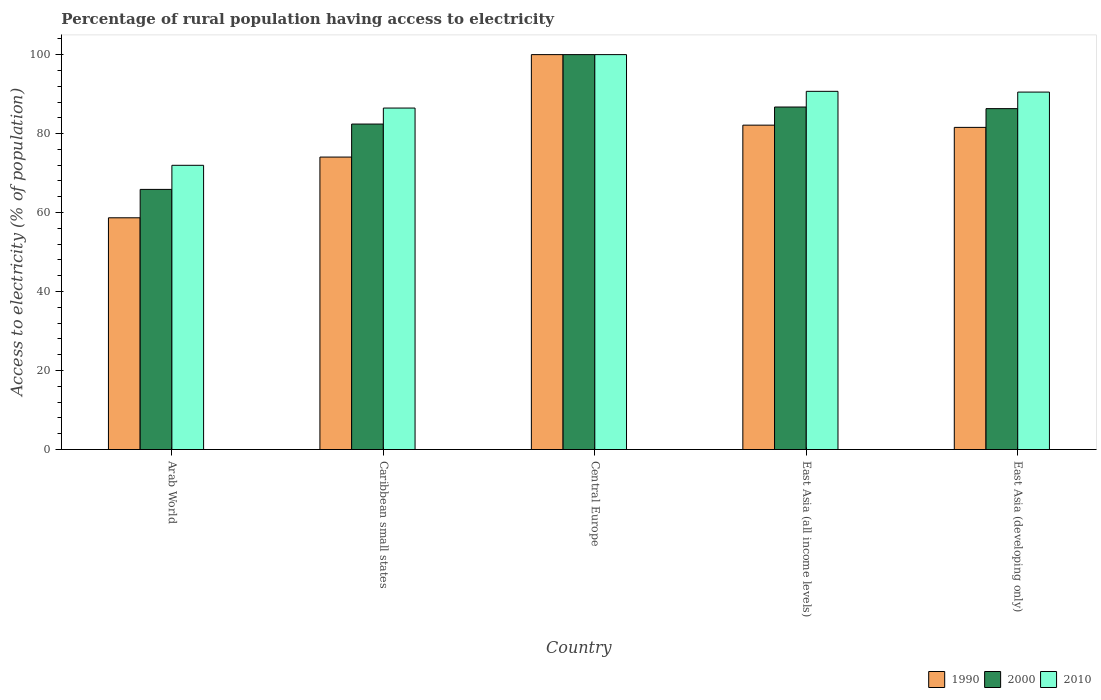How many groups of bars are there?
Keep it short and to the point. 5. What is the label of the 1st group of bars from the left?
Provide a short and direct response. Arab World. Across all countries, what is the maximum percentage of rural population having access to electricity in 1990?
Ensure brevity in your answer.  100. Across all countries, what is the minimum percentage of rural population having access to electricity in 2010?
Keep it short and to the point. 71.97. In which country was the percentage of rural population having access to electricity in 2000 maximum?
Ensure brevity in your answer.  Central Europe. In which country was the percentage of rural population having access to electricity in 2010 minimum?
Ensure brevity in your answer.  Arab World. What is the total percentage of rural population having access to electricity in 2010 in the graph?
Provide a succinct answer. 439.66. What is the difference between the percentage of rural population having access to electricity in 2010 in Caribbean small states and that in East Asia (developing only)?
Keep it short and to the point. -4.04. What is the difference between the percentage of rural population having access to electricity in 2010 in East Asia (all income levels) and the percentage of rural population having access to electricity in 1990 in East Asia (developing only)?
Your response must be concise. 9.13. What is the average percentage of rural population having access to electricity in 2000 per country?
Provide a short and direct response. 84.27. What is the difference between the percentage of rural population having access to electricity of/in 2010 and percentage of rural population having access to electricity of/in 2000 in East Asia (all income levels)?
Offer a very short reply. 3.97. In how many countries, is the percentage of rural population having access to electricity in 2000 greater than 8 %?
Provide a succinct answer. 5. What is the ratio of the percentage of rural population having access to electricity in 1990 in Arab World to that in Caribbean small states?
Your response must be concise. 0.79. Is the difference between the percentage of rural population having access to electricity in 2010 in Caribbean small states and East Asia (developing only) greater than the difference between the percentage of rural population having access to electricity in 2000 in Caribbean small states and East Asia (developing only)?
Offer a terse response. No. What is the difference between the highest and the second highest percentage of rural population having access to electricity in 1990?
Your response must be concise. -0.57. What is the difference between the highest and the lowest percentage of rural population having access to electricity in 2010?
Your response must be concise. 28.03. In how many countries, is the percentage of rural population having access to electricity in 2010 greater than the average percentage of rural population having access to electricity in 2010 taken over all countries?
Make the answer very short. 3. Is the sum of the percentage of rural population having access to electricity in 1990 in Arab World and Caribbean small states greater than the maximum percentage of rural population having access to electricity in 2010 across all countries?
Your answer should be very brief. Yes. What does the 3rd bar from the left in Arab World represents?
Give a very brief answer. 2010. What does the 2nd bar from the right in Central Europe represents?
Ensure brevity in your answer.  2000. Are all the bars in the graph horizontal?
Your answer should be very brief. No. How many countries are there in the graph?
Keep it short and to the point. 5. Are the values on the major ticks of Y-axis written in scientific E-notation?
Offer a very short reply. No. Does the graph contain any zero values?
Your response must be concise. No. Does the graph contain grids?
Provide a succinct answer. No. Where does the legend appear in the graph?
Keep it short and to the point. Bottom right. What is the title of the graph?
Ensure brevity in your answer.  Percentage of rural population having access to electricity. What is the label or title of the Y-axis?
Your response must be concise. Access to electricity (% of population). What is the Access to electricity (% of population) in 1990 in Arab World?
Provide a succinct answer. 58.68. What is the Access to electricity (% of population) of 2000 in Arab World?
Offer a very short reply. 65.87. What is the Access to electricity (% of population) of 2010 in Arab World?
Provide a short and direct response. 71.97. What is the Access to electricity (% of population) of 1990 in Caribbean small states?
Keep it short and to the point. 74.06. What is the Access to electricity (% of population) of 2000 in Caribbean small states?
Make the answer very short. 82.42. What is the Access to electricity (% of population) of 2010 in Caribbean small states?
Your answer should be very brief. 86.47. What is the Access to electricity (% of population) of 2000 in Central Europe?
Offer a very short reply. 100. What is the Access to electricity (% of population) of 1990 in East Asia (all income levels)?
Keep it short and to the point. 82.14. What is the Access to electricity (% of population) of 2000 in East Asia (all income levels)?
Make the answer very short. 86.73. What is the Access to electricity (% of population) of 2010 in East Asia (all income levels)?
Provide a short and direct response. 90.7. What is the Access to electricity (% of population) in 1990 in East Asia (developing only)?
Give a very brief answer. 81.57. What is the Access to electricity (% of population) in 2000 in East Asia (developing only)?
Offer a terse response. 86.32. What is the Access to electricity (% of population) of 2010 in East Asia (developing only)?
Your response must be concise. 90.51. Across all countries, what is the minimum Access to electricity (% of population) in 1990?
Ensure brevity in your answer.  58.68. Across all countries, what is the minimum Access to electricity (% of population) in 2000?
Your response must be concise. 65.87. Across all countries, what is the minimum Access to electricity (% of population) of 2010?
Offer a terse response. 71.97. What is the total Access to electricity (% of population) in 1990 in the graph?
Offer a terse response. 396.45. What is the total Access to electricity (% of population) of 2000 in the graph?
Offer a very short reply. 421.34. What is the total Access to electricity (% of population) in 2010 in the graph?
Your answer should be very brief. 439.66. What is the difference between the Access to electricity (% of population) in 1990 in Arab World and that in Caribbean small states?
Your answer should be very brief. -15.38. What is the difference between the Access to electricity (% of population) of 2000 in Arab World and that in Caribbean small states?
Offer a very short reply. -16.55. What is the difference between the Access to electricity (% of population) of 2010 in Arab World and that in Caribbean small states?
Provide a succinct answer. -14.5. What is the difference between the Access to electricity (% of population) of 1990 in Arab World and that in Central Europe?
Your answer should be very brief. -41.32. What is the difference between the Access to electricity (% of population) of 2000 in Arab World and that in Central Europe?
Provide a succinct answer. -34.13. What is the difference between the Access to electricity (% of population) of 2010 in Arab World and that in Central Europe?
Provide a succinct answer. -28.03. What is the difference between the Access to electricity (% of population) of 1990 in Arab World and that in East Asia (all income levels)?
Ensure brevity in your answer.  -23.46. What is the difference between the Access to electricity (% of population) in 2000 in Arab World and that in East Asia (all income levels)?
Your answer should be very brief. -20.86. What is the difference between the Access to electricity (% of population) of 2010 in Arab World and that in East Asia (all income levels)?
Provide a short and direct response. -18.73. What is the difference between the Access to electricity (% of population) in 1990 in Arab World and that in East Asia (developing only)?
Your response must be concise. -22.89. What is the difference between the Access to electricity (% of population) of 2000 in Arab World and that in East Asia (developing only)?
Offer a very short reply. -20.45. What is the difference between the Access to electricity (% of population) of 2010 in Arab World and that in East Asia (developing only)?
Your answer should be compact. -18.54. What is the difference between the Access to electricity (% of population) in 1990 in Caribbean small states and that in Central Europe?
Your response must be concise. -25.94. What is the difference between the Access to electricity (% of population) of 2000 in Caribbean small states and that in Central Europe?
Offer a terse response. -17.58. What is the difference between the Access to electricity (% of population) of 2010 in Caribbean small states and that in Central Europe?
Give a very brief answer. -13.53. What is the difference between the Access to electricity (% of population) in 1990 in Caribbean small states and that in East Asia (all income levels)?
Your answer should be very brief. -8.09. What is the difference between the Access to electricity (% of population) in 2000 in Caribbean small states and that in East Asia (all income levels)?
Ensure brevity in your answer.  -4.31. What is the difference between the Access to electricity (% of population) in 2010 in Caribbean small states and that in East Asia (all income levels)?
Your answer should be compact. -4.23. What is the difference between the Access to electricity (% of population) in 1990 in Caribbean small states and that in East Asia (developing only)?
Offer a very short reply. -7.52. What is the difference between the Access to electricity (% of population) in 2000 in Caribbean small states and that in East Asia (developing only)?
Make the answer very short. -3.91. What is the difference between the Access to electricity (% of population) in 2010 in Caribbean small states and that in East Asia (developing only)?
Provide a short and direct response. -4.04. What is the difference between the Access to electricity (% of population) in 1990 in Central Europe and that in East Asia (all income levels)?
Make the answer very short. 17.86. What is the difference between the Access to electricity (% of population) in 2000 in Central Europe and that in East Asia (all income levels)?
Make the answer very short. 13.27. What is the difference between the Access to electricity (% of population) of 2010 in Central Europe and that in East Asia (all income levels)?
Offer a very short reply. 9.3. What is the difference between the Access to electricity (% of population) in 1990 in Central Europe and that in East Asia (developing only)?
Provide a short and direct response. 18.43. What is the difference between the Access to electricity (% of population) of 2000 in Central Europe and that in East Asia (developing only)?
Your response must be concise. 13.68. What is the difference between the Access to electricity (% of population) of 2010 in Central Europe and that in East Asia (developing only)?
Keep it short and to the point. 9.49. What is the difference between the Access to electricity (% of population) of 1990 in East Asia (all income levels) and that in East Asia (developing only)?
Offer a terse response. 0.57. What is the difference between the Access to electricity (% of population) of 2000 in East Asia (all income levels) and that in East Asia (developing only)?
Offer a terse response. 0.41. What is the difference between the Access to electricity (% of population) in 2010 in East Asia (all income levels) and that in East Asia (developing only)?
Offer a terse response. 0.19. What is the difference between the Access to electricity (% of population) in 1990 in Arab World and the Access to electricity (% of population) in 2000 in Caribbean small states?
Your answer should be very brief. -23.74. What is the difference between the Access to electricity (% of population) of 1990 in Arab World and the Access to electricity (% of population) of 2010 in Caribbean small states?
Ensure brevity in your answer.  -27.79. What is the difference between the Access to electricity (% of population) in 2000 in Arab World and the Access to electricity (% of population) in 2010 in Caribbean small states?
Ensure brevity in your answer.  -20.6. What is the difference between the Access to electricity (% of population) of 1990 in Arab World and the Access to electricity (% of population) of 2000 in Central Europe?
Your answer should be compact. -41.32. What is the difference between the Access to electricity (% of population) of 1990 in Arab World and the Access to electricity (% of population) of 2010 in Central Europe?
Give a very brief answer. -41.32. What is the difference between the Access to electricity (% of population) of 2000 in Arab World and the Access to electricity (% of population) of 2010 in Central Europe?
Your answer should be very brief. -34.13. What is the difference between the Access to electricity (% of population) in 1990 in Arab World and the Access to electricity (% of population) in 2000 in East Asia (all income levels)?
Keep it short and to the point. -28.05. What is the difference between the Access to electricity (% of population) in 1990 in Arab World and the Access to electricity (% of population) in 2010 in East Asia (all income levels)?
Your answer should be very brief. -32.02. What is the difference between the Access to electricity (% of population) of 2000 in Arab World and the Access to electricity (% of population) of 2010 in East Asia (all income levels)?
Your response must be concise. -24.83. What is the difference between the Access to electricity (% of population) of 1990 in Arab World and the Access to electricity (% of population) of 2000 in East Asia (developing only)?
Ensure brevity in your answer.  -27.64. What is the difference between the Access to electricity (% of population) in 1990 in Arab World and the Access to electricity (% of population) in 2010 in East Asia (developing only)?
Make the answer very short. -31.83. What is the difference between the Access to electricity (% of population) of 2000 in Arab World and the Access to electricity (% of population) of 2010 in East Asia (developing only)?
Your answer should be compact. -24.64. What is the difference between the Access to electricity (% of population) of 1990 in Caribbean small states and the Access to electricity (% of population) of 2000 in Central Europe?
Your answer should be very brief. -25.94. What is the difference between the Access to electricity (% of population) in 1990 in Caribbean small states and the Access to electricity (% of population) in 2010 in Central Europe?
Offer a terse response. -25.94. What is the difference between the Access to electricity (% of population) of 2000 in Caribbean small states and the Access to electricity (% of population) of 2010 in Central Europe?
Provide a succinct answer. -17.58. What is the difference between the Access to electricity (% of population) in 1990 in Caribbean small states and the Access to electricity (% of population) in 2000 in East Asia (all income levels)?
Keep it short and to the point. -12.67. What is the difference between the Access to electricity (% of population) of 1990 in Caribbean small states and the Access to electricity (% of population) of 2010 in East Asia (all income levels)?
Provide a succinct answer. -16.65. What is the difference between the Access to electricity (% of population) of 2000 in Caribbean small states and the Access to electricity (% of population) of 2010 in East Asia (all income levels)?
Your answer should be very brief. -8.29. What is the difference between the Access to electricity (% of population) in 1990 in Caribbean small states and the Access to electricity (% of population) in 2000 in East Asia (developing only)?
Make the answer very short. -12.27. What is the difference between the Access to electricity (% of population) of 1990 in Caribbean small states and the Access to electricity (% of population) of 2010 in East Asia (developing only)?
Ensure brevity in your answer.  -16.46. What is the difference between the Access to electricity (% of population) in 2000 in Caribbean small states and the Access to electricity (% of population) in 2010 in East Asia (developing only)?
Your answer should be compact. -8.1. What is the difference between the Access to electricity (% of population) of 1990 in Central Europe and the Access to electricity (% of population) of 2000 in East Asia (all income levels)?
Your answer should be very brief. 13.27. What is the difference between the Access to electricity (% of population) in 1990 in Central Europe and the Access to electricity (% of population) in 2010 in East Asia (all income levels)?
Your answer should be compact. 9.3. What is the difference between the Access to electricity (% of population) in 2000 in Central Europe and the Access to electricity (% of population) in 2010 in East Asia (all income levels)?
Keep it short and to the point. 9.3. What is the difference between the Access to electricity (% of population) of 1990 in Central Europe and the Access to electricity (% of population) of 2000 in East Asia (developing only)?
Provide a succinct answer. 13.68. What is the difference between the Access to electricity (% of population) of 1990 in Central Europe and the Access to electricity (% of population) of 2010 in East Asia (developing only)?
Make the answer very short. 9.49. What is the difference between the Access to electricity (% of population) of 2000 in Central Europe and the Access to electricity (% of population) of 2010 in East Asia (developing only)?
Ensure brevity in your answer.  9.49. What is the difference between the Access to electricity (% of population) of 1990 in East Asia (all income levels) and the Access to electricity (% of population) of 2000 in East Asia (developing only)?
Your answer should be compact. -4.18. What is the difference between the Access to electricity (% of population) in 1990 in East Asia (all income levels) and the Access to electricity (% of population) in 2010 in East Asia (developing only)?
Offer a terse response. -8.37. What is the difference between the Access to electricity (% of population) of 2000 in East Asia (all income levels) and the Access to electricity (% of population) of 2010 in East Asia (developing only)?
Keep it short and to the point. -3.78. What is the average Access to electricity (% of population) of 1990 per country?
Offer a terse response. 79.29. What is the average Access to electricity (% of population) of 2000 per country?
Provide a succinct answer. 84.27. What is the average Access to electricity (% of population) in 2010 per country?
Your answer should be compact. 87.93. What is the difference between the Access to electricity (% of population) in 1990 and Access to electricity (% of population) in 2000 in Arab World?
Provide a succinct answer. -7.19. What is the difference between the Access to electricity (% of population) of 1990 and Access to electricity (% of population) of 2010 in Arab World?
Provide a succinct answer. -13.29. What is the difference between the Access to electricity (% of population) of 2000 and Access to electricity (% of population) of 2010 in Arab World?
Your response must be concise. -6.1. What is the difference between the Access to electricity (% of population) of 1990 and Access to electricity (% of population) of 2000 in Caribbean small states?
Keep it short and to the point. -8.36. What is the difference between the Access to electricity (% of population) in 1990 and Access to electricity (% of population) in 2010 in Caribbean small states?
Ensure brevity in your answer.  -12.41. What is the difference between the Access to electricity (% of population) in 2000 and Access to electricity (% of population) in 2010 in Caribbean small states?
Ensure brevity in your answer.  -4.05. What is the difference between the Access to electricity (% of population) in 1990 and Access to electricity (% of population) in 2000 in East Asia (all income levels)?
Your answer should be compact. -4.59. What is the difference between the Access to electricity (% of population) in 1990 and Access to electricity (% of population) in 2010 in East Asia (all income levels)?
Give a very brief answer. -8.56. What is the difference between the Access to electricity (% of population) of 2000 and Access to electricity (% of population) of 2010 in East Asia (all income levels)?
Provide a succinct answer. -3.97. What is the difference between the Access to electricity (% of population) of 1990 and Access to electricity (% of population) of 2000 in East Asia (developing only)?
Your response must be concise. -4.75. What is the difference between the Access to electricity (% of population) of 1990 and Access to electricity (% of population) of 2010 in East Asia (developing only)?
Your response must be concise. -8.94. What is the difference between the Access to electricity (% of population) of 2000 and Access to electricity (% of population) of 2010 in East Asia (developing only)?
Provide a succinct answer. -4.19. What is the ratio of the Access to electricity (% of population) of 1990 in Arab World to that in Caribbean small states?
Ensure brevity in your answer.  0.79. What is the ratio of the Access to electricity (% of population) of 2000 in Arab World to that in Caribbean small states?
Your answer should be very brief. 0.8. What is the ratio of the Access to electricity (% of population) of 2010 in Arab World to that in Caribbean small states?
Your answer should be very brief. 0.83. What is the ratio of the Access to electricity (% of population) of 1990 in Arab World to that in Central Europe?
Ensure brevity in your answer.  0.59. What is the ratio of the Access to electricity (% of population) in 2000 in Arab World to that in Central Europe?
Offer a very short reply. 0.66. What is the ratio of the Access to electricity (% of population) in 2010 in Arab World to that in Central Europe?
Make the answer very short. 0.72. What is the ratio of the Access to electricity (% of population) of 1990 in Arab World to that in East Asia (all income levels)?
Keep it short and to the point. 0.71. What is the ratio of the Access to electricity (% of population) of 2000 in Arab World to that in East Asia (all income levels)?
Provide a succinct answer. 0.76. What is the ratio of the Access to electricity (% of population) in 2010 in Arab World to that in East Asia (all income levels)?
Keep it short and to the point. 0.79. What is the ratio of the Access to electricity (% of population) of 1990 in Arab World to that in East Asia (developing only)?
Make the answer very short. 0.72. What is the ratio of the Access to electricity (% of population) in 2000 in Arab World to that in East Asia (developing only)?
Give a very brief answer. 0.76. What is the ratio of the Access to electricity (% of population) of 2010 in Arab World to that in East Asia (developing only)?
Give a very brief answer. 0.8. What is the ratio of the Access to electricity (% of population) of 1990 in Caribbean small states to that in Central Europe?
Ensure brevity in your answer.  0.74. What is the ratio of the Access to electricity (% of population) in 2000 in Caribbean small states to that in Central Europe?
Your answer should be compact. 0.82. What is the ratio of the Access to electricity (% of population) of 2010 in Caribbean small states to that in Central Europe?
Ensure brevity in your answer.  0.86. What is the ratio of the Access to electricity (% of population) of 1990 in Caribbean small states to that in East Asia (all income levels)?
Keep it short and to the point. 0.9. What is the ratio of the Access to electricity (% of population) in 2000 in Caribbean small states to that in East Asia (all income levels)?
Your answer should be very brief. 0.95. What is the ratio of the Access to electricity (% of population) of 2010 in Caribbean small states to that in East Asia (all income levels)?
Ensure brevity in your answer.  0.95. What is the ratio of the Access to electricity (% of population) of 1990 in Caribbean small states to that in East Asia (developing only)?
Provide a succinct answer. 0.91. What is the ratio of the Access to electricity (% of population) of 2000 in Caribbean small states to that in East Asia (developing only)?
Provide a short and direct response. 0.95. What is the ratio of the Access to electricity (% of population) in 2010 in Caribbean small states to that in East Asia (developing only)?
Your answer should be compact. 0.96. What is the ratio of the Access to electricity (% of population) in 1990 in Central Europe to that in East Asia (all income levels)?
Your answer should be very brief. 1.22. What is the ratio of the Access to electricity (% of population) in 2000 in Central Europe to that in East Asia (all income levels)?
Provide a short and direct response. 1.15. What is the ratio of the Access to electricity (% of population) in 2010 in Central Europe to that in East Asia (all income levels)?
Provide a short and direct response. 1.1. What is the ratio of the Access to electricity (% of population) of 1990 in Central Europe to that in East Asia (developing only)?
Offer a very short reply. 1.23. What is the ratio of the Access to electricity (% of population) in 2000 in Central Europe to that in East Asia (developing only)?
Offer a very short reply. 1.16. What is the ratio of the Access to electricity (% of population) of 2010 in Central Europe to that in East Asia (developing only)?
Keep it short and to the point. 1.1. What is the ratio of the Access to electricity (% of population) in 2000 in East Asia (all income levels) to that in East Asia (developing only)?
Keep it short and to the point. 1. What is the difference between the highest and the second highest Access to electricity (% of population) in 1990?
Your answer should be very brief. 17.86. What is the difference between the highest and the second highest Access to electricity (% of population) of 2000?
Provide a succinct answer. 13.27. What is the difference between the highest and the second highest Access to electricity (% of population) of 2010?
Your response must be concise. 9.3. What is the difference between the highest and the lowest Access to electricity (% of population) in 1990?
Offer a terse response. 41.32. What is the difference between the highest and the lowest Access to electricity (% of population) in 2000?
Make the answer very short. 34.13. What is the difference between the highest and the lowest Access to electricity (% of population) in 2010?
Offer a very short reply. 28.03. 